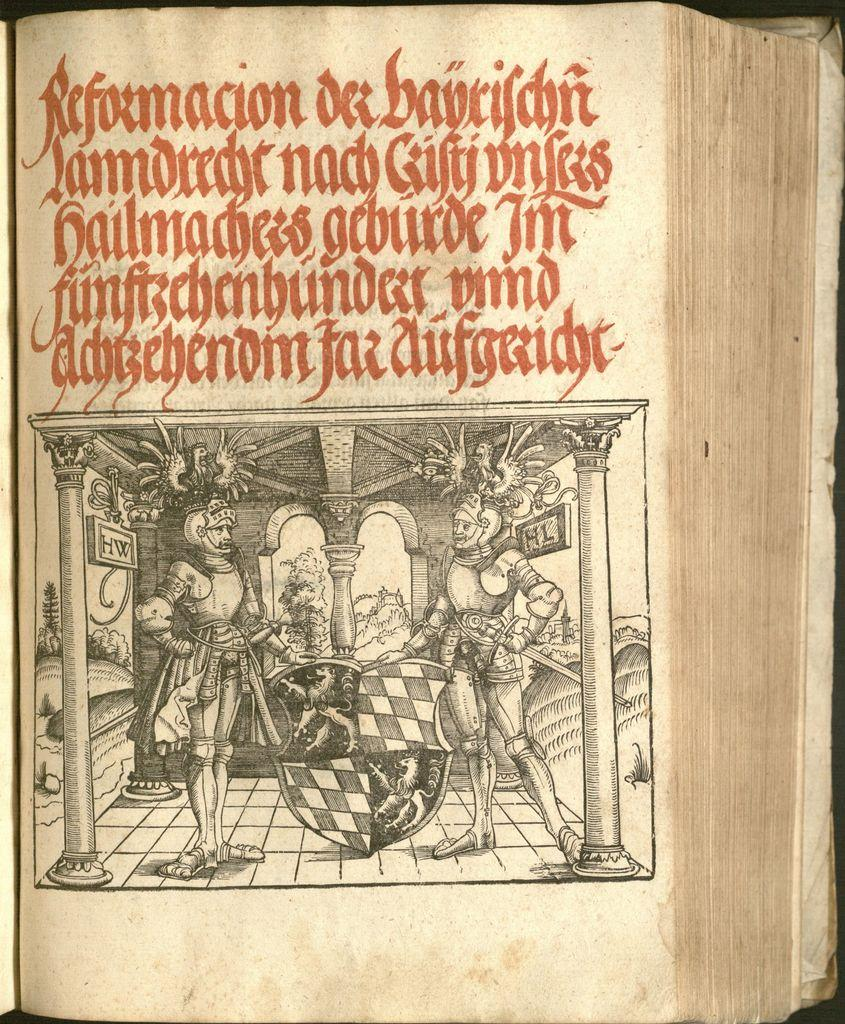<image>
Describe the image concisely. A book is opened to a page illustrated with men in armor and the first word at the top of the page is Reformacion. 